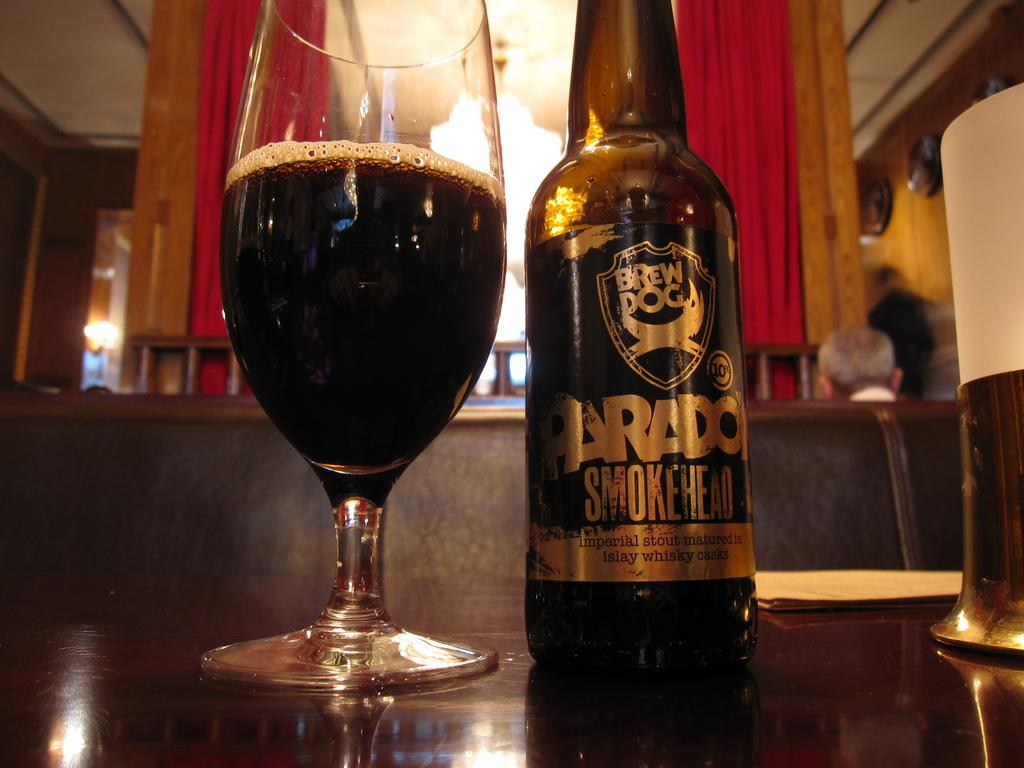What is in the bottle that is visible in the image? There is a bottle with a label in the image. What is in the glass that is visible in the image? There is a glass with a drink in the image. Where are the bottle and glass placed in the image? The bottle and glass are placed on a table in the image. What can be seen in the background of the image? There is a person, a sofa, and curtains visible in the background of the image. How many tax forms are visible on the table in the image? There are no tax forms visible on the table in the image. What type of farm can be seen in the background of the image? There is no farm present in the image; it features a person, a sofa, and curtains in the background. 